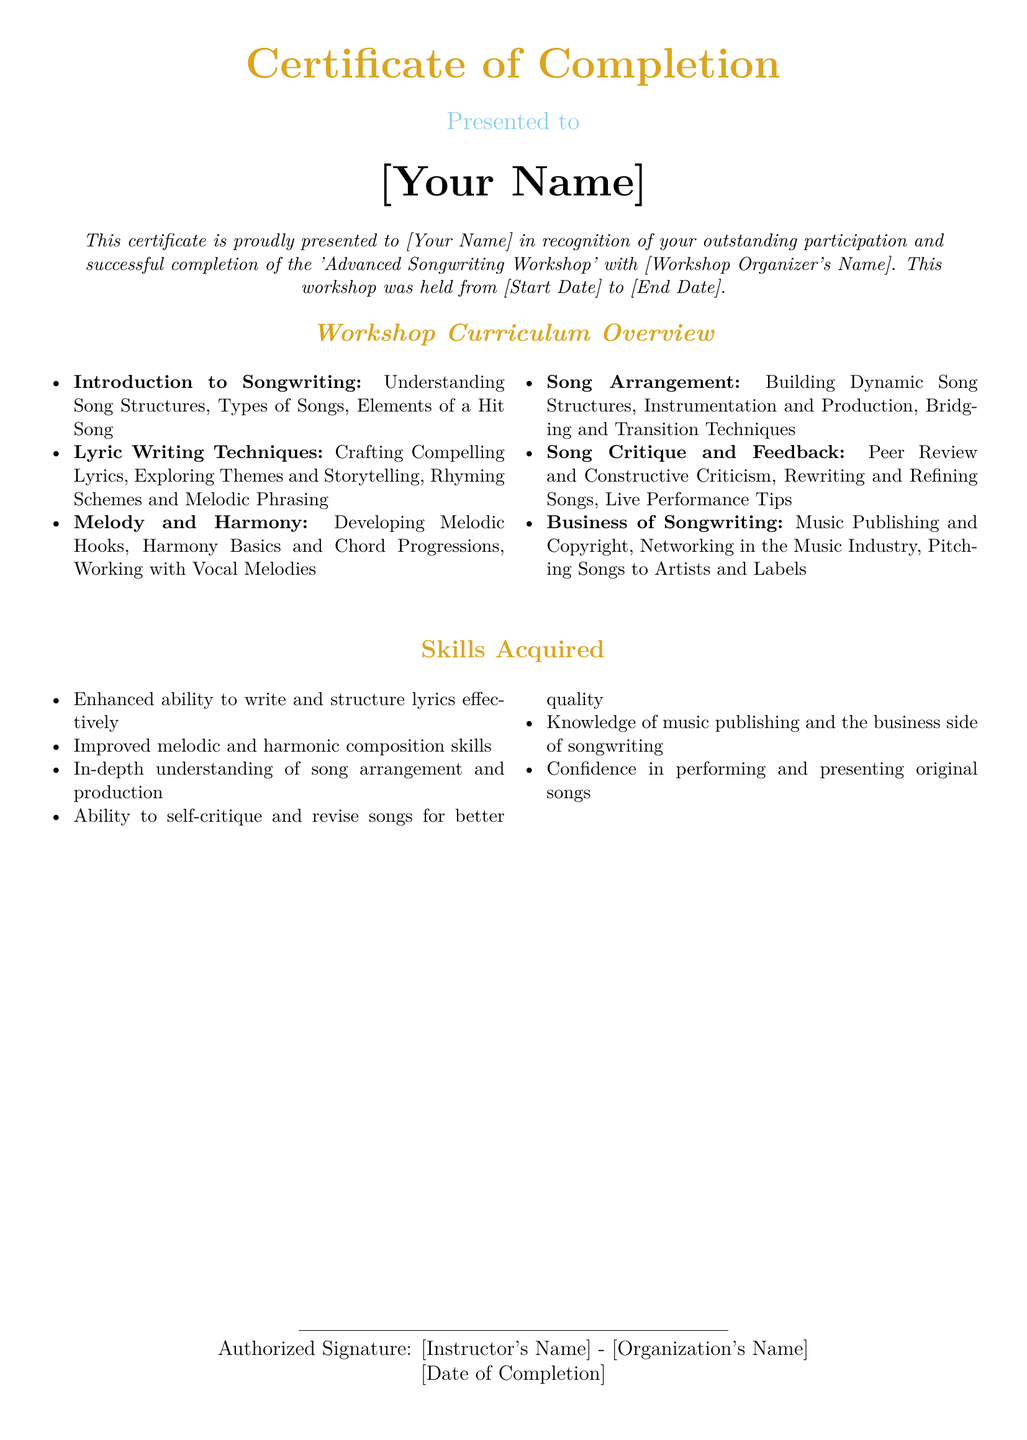What is the name of the workshop? The name of the workshop is specified in the document as 'Advanced Songwriting Workshop'.
Answer: Advanced Songwriting Workshop Who is this certificate presented to? The certificate is presented to the individual whose name is filled in the document.
Answer: [Your Name] What color is used for the workshop title? The color used for the workshop title is goldaccent.
Answer: goldaccent What is one of the lyric writing techniques taught in the workshop? The document lists several lyric writing techniques, one of which is 'Crafting Compelling Lyrics'.
Answer: Crafting Compelling Lyrics What are the dates for the workshop? The dates are shown in the document as '[Start Date] to [End Date]'.
Answer: [Start Date] to [End Date] How many skills are listed as acquired? The document contains six skills listed under 'Skills Acquired'.
Answer: 6 What type of feedback is included in the workshop? The document specifies 'Peer Review and Constructive Criticism' as a form of feedback.
Answer: Peer Review and Constructive Criticism Who signs the certificate? The certificate is signed by '[Instructor's Name]' from '[Organization's Name]'.
Answer: [Instructor's Name] - [Organization's Name] What is one topic covered in the business of songwriting section? The document mentions 'Music Publishing and Copyright' as a topic covered.
Answer: Music Publishing and Copyright 